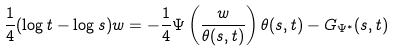Convert formula to latex. <formula><loc_0><loc_0><loc_500><loc_500>\frac { 1 } { 4 } ( \log t - \log s ) w & = - \frac { 1 } { 4 } \Psi \left ( \frac { w } { \theta ( s , t ) } \right ) \theta ( s , t ) - G _ { \Psi ^ { * } } ( s , t )</formula> 